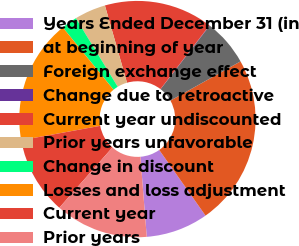<chart> <loc_0><loc_0><loc_500><loc_500><pie_chart><fcel>Years Ended December 31 (in<fcel>at beginning of year<fcel>Foreign exchange effect<fcel>Change due to retroactive<fcel>Current year undiscounted<fcel>Prior years unfavorable<fcel>Change in discount<fcel>Losses and loss adjustment<fcel>Current year<fcel>Prior years<nl><fcel>8.52%<fcel>23.34%<fcel>6.4%<fcel>0.05%<fcel>14.87%<fcel>4.28%<fcel>2.16%<fcel>16.99%<fcel>10.64%<fcel>12.75%<nl></chart> 